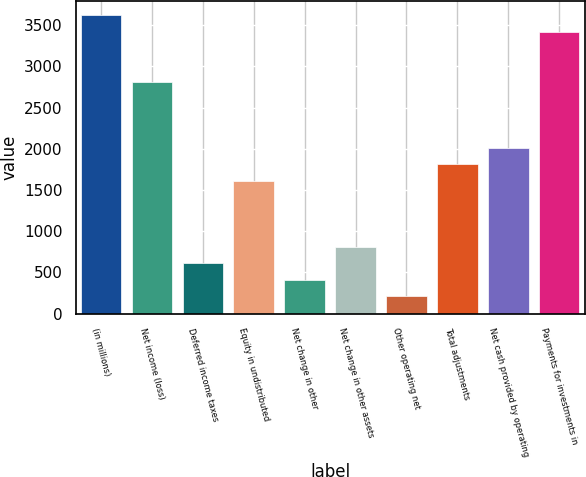Convert chart. <chart><loc_0><loc_0><loc_500><loc_500><bar_chart><fcel>(in millions)<fcel>Net income (loss)<fcel>Deferred income taxes<fcel>Equity in undistributed<fcel>Net change in other<fcel>Net change in other assets<fcel>Other operating net<fcel>Total adjustments<fcel>Net cash provided by operating<fcel>Payments for investments in<nl><fcel>3616.4<fcel>2815.2<fcel>611.9<fcel>1613.4<fcel>411.6<fcel>812.2<fcel>211.3<fcel>1813.7<fcel>2014<fcel>3416.1<nl></chart> 